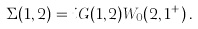<formula> <loc_0><loc_0><loc_500><loc_500>\Sigma ( 1 , 2 ) = i G ( 1 , 2 ) W _ { 0 } ( 2 , 1 ^ { + } ) \, .</formula> 